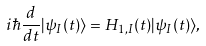<formula> <loc_0><loc_0><loc_500><loc_500>i \hbar { \frac { d } { d t } } | \psi _ { I } ( t ) \rangle = H _ { 1 , { I } } ( t ) | \psi _ { I } ( t ) \rangle ,</formula> 